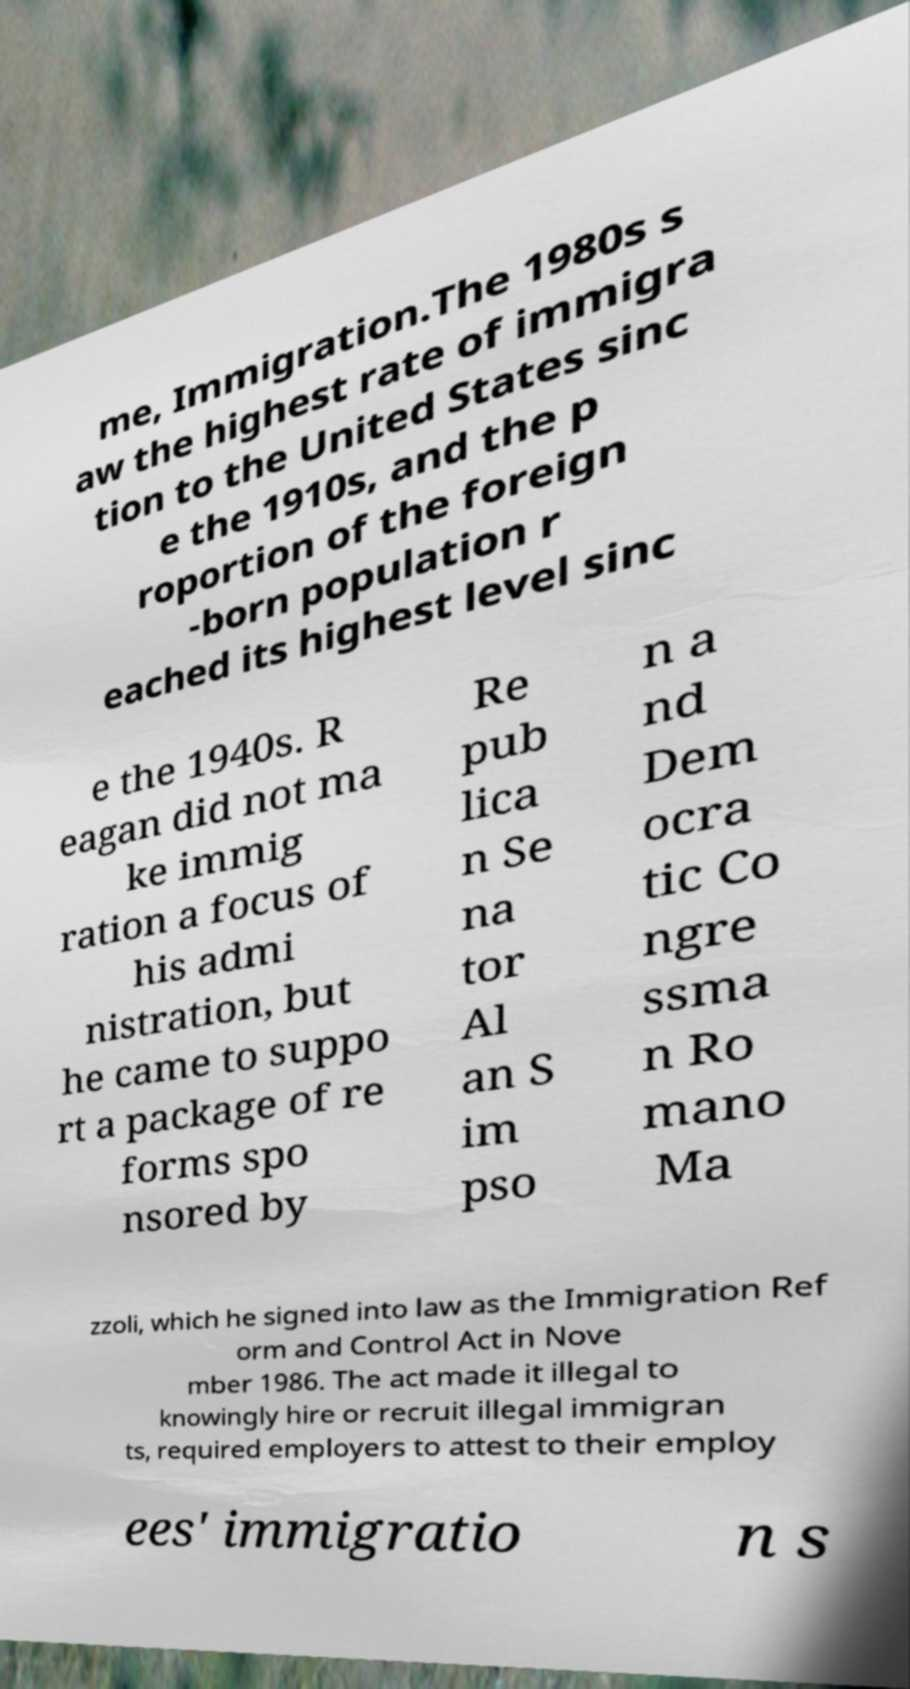Can you read and provide the text displayed in the image?This photo seems to have some interesting text. Can you extract and type it out for me? me, Immigration.The 1980s s aw the highest rate of immigra tion to the United States sinc e the 1910s, and the p roportion of the foreign -born population r eached its highest level sinc e the 1940s. R eagan did not ma ke immig ration a focus of his admi nistration, but he came to suppo rt a package of re forms spo nsored by Re pub lica n Se na tor Al an S im pso n a nd Dem ocra tic Co ngre ssma n Ro mano Ma zzoli, which he signed into law as the Immigration Ref orm and Control Act in Nove mber 1986. The act made it illegal to knowingly hire or recruit illegal immigran ts, required employers to attest to their employ ees' immigratio n s 